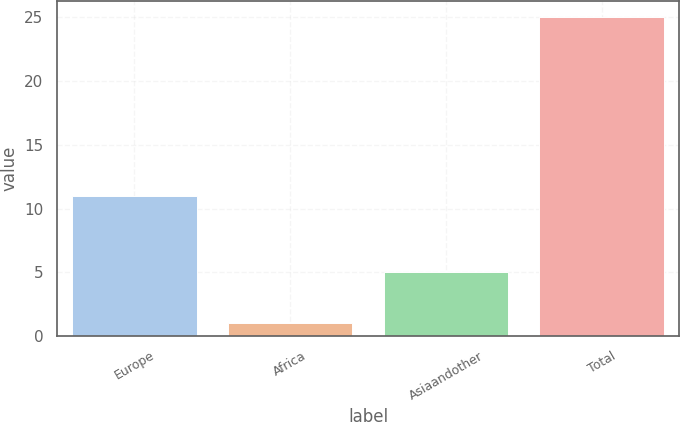<chart> <loc_0><loc_0><loc_500><loc_500><bar_chart><fcel>Europe<fcel>Africa<fcel>Asiaandother<fcel>Total<nl><fcel>11<fcel>1<fcel>5<fcel>25<nl></chart> 